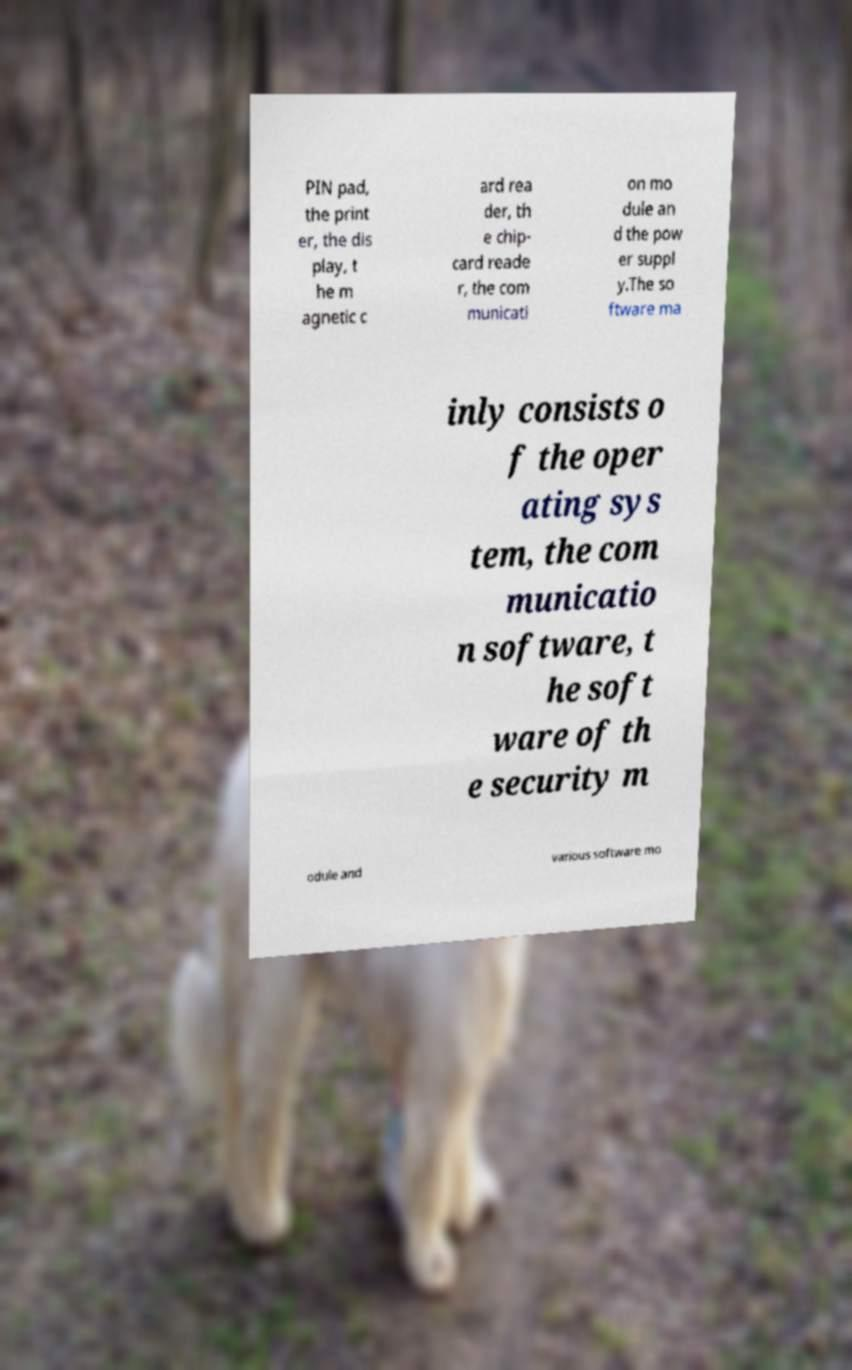What messages or text are displayed in this image? I need them in a readable, typed format. PIN pad, the print er, the dis play, t he m agnetic c ard rea der, th e chip- card reade r, the com municati on mo dule an d the pow er suppl y.The so ftware ma inly consists o f the oper ating sys tem, the com municatio n software, t he soft ware of th e security m odule and various software mo 